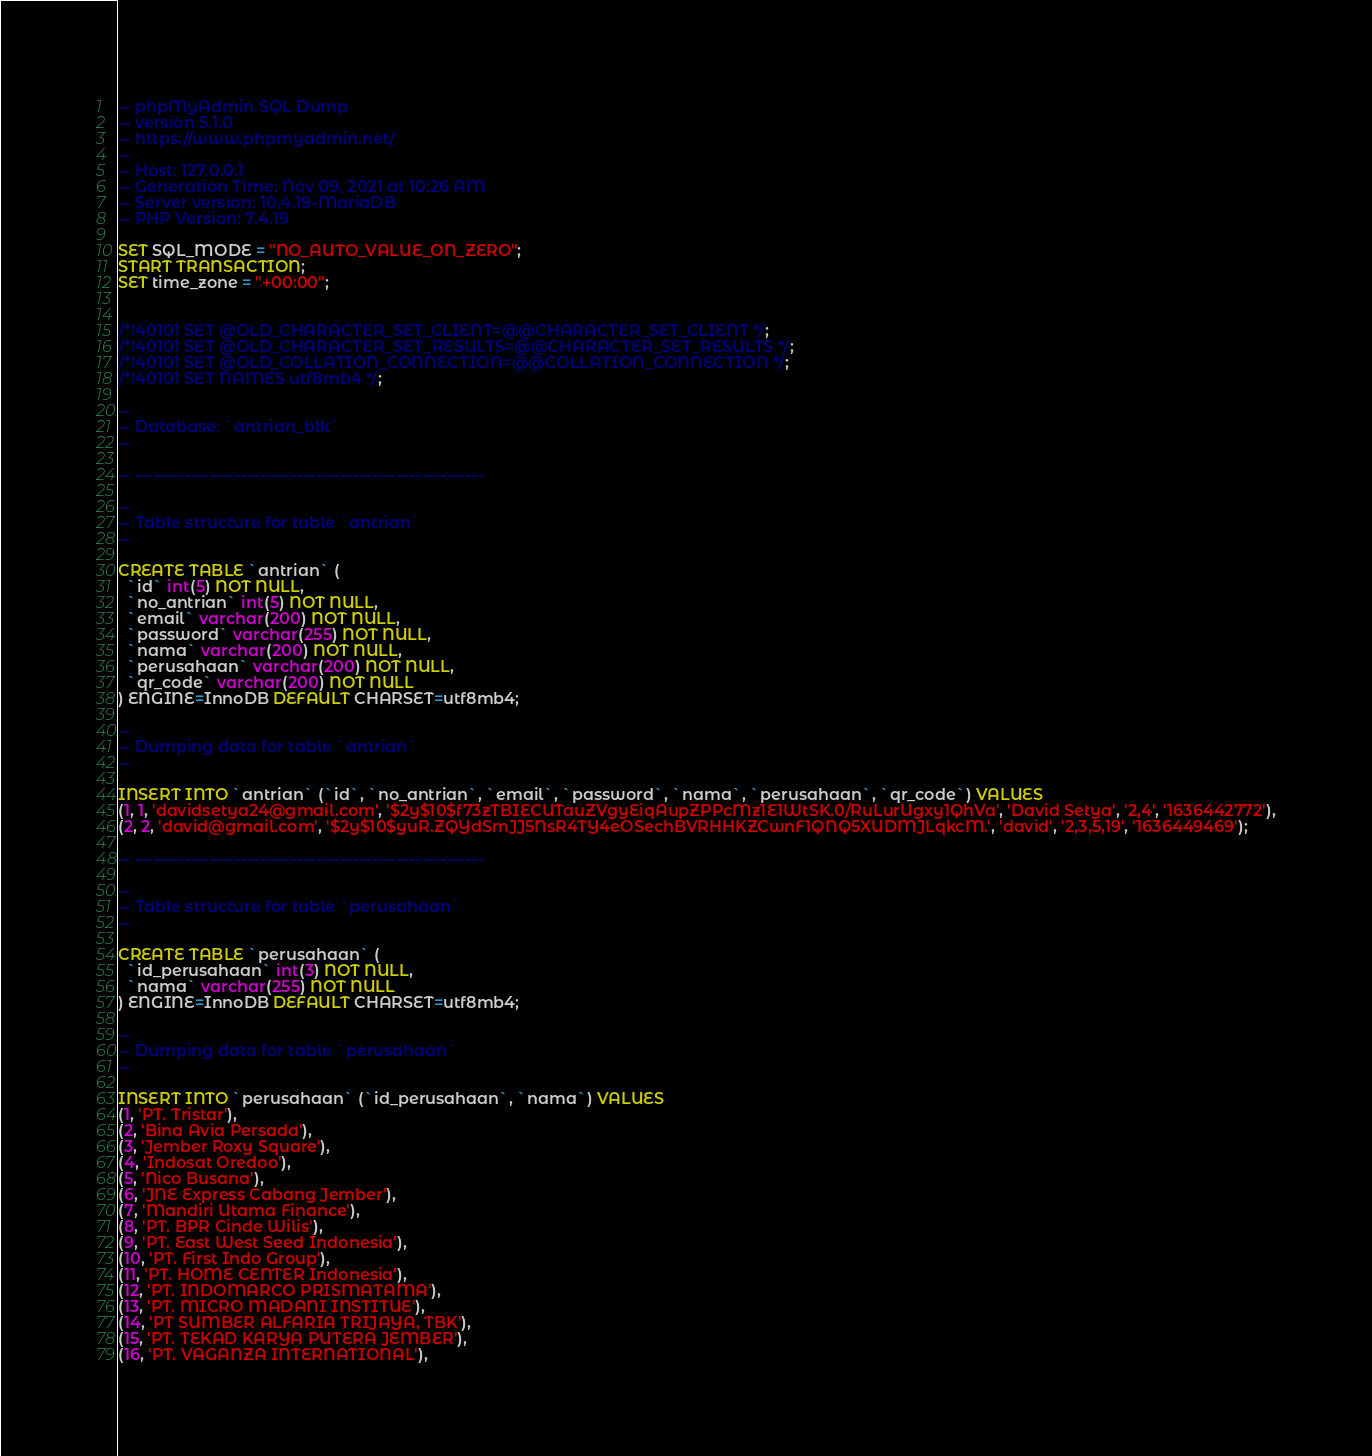<code> <loc_0><loc_0><loc_500><loc_500><_SQL_>-- phpMyAdmin SQL Dump
-- version 5.1.0
-- https://www.phpmyadmin.net/
--
-- Host: 127.0.0.1
-- Generation Time: Nov 09, 2021 at 10:26 AM
-- Server version: 10.4.19-MariaDB
-- PHP Version: 7.4.19

SET SQL_MODE = "NO_AUTO_VALUE_ON_ZERO";
START TRANSACTION;
SET time_zone = "+00:00";


/*!40101 SET @OLD_CHARACTER_SET_CLIENT=@@CHARACTER_SET_CLIENT */;
/*!40101 SET @OLD_CHARACTER_SET_RESULTS=@@CHARACTER_SET_RESULTS */;
/*!40101 SET @OLD_COLLATION_CONNECTION=@@COLLATION_CONNECTION */;
/*!40101 SET NAMES utf8mb4 */;

--
-- Database: `antrian_blk`
--

-- --------------------------------------------------------

--
-- Table structure for table `antrian`
--

CREATE TABLE `antrian` (
  `id` int(5) NOT NULL,
  `no_antrian` int(5) NOT NULL,
  `email` varchar(200) NOT NULL,
  `password` varchar(255) NOT NULL,
  `nama` varchar(200) NOT NULL,
  `perusahaan` varchar(200) NOT NULL,
  `qr_code` varchar(200) NOT NULL
) ENGINE=InnoDB DEFAULT CHARSET=utf8mb4;

--
-- Dumping data for table `antrian`
--

INSERT INTO `antrian` (`id`, `no_antrian`, `email`, `password`, `nama`, `perusahaan`, `qr_code`) VALUES
(1, 1, 'davidsetya24@gmail.com', '$2y$10$f73zTBIECUTauZVgyEiqAupZPPcMz1E1WtSK.0/RuLurUgxy1QhVa', 'David Setya', '2,4', '1636442772'),
(2, 2, 'david@gmail.com', '$2y$10$yuR.ZQYdSmJJ5NsR4TY4eOSechBVRHHKZCwnF1QNQ5XUDMJLqkcM.', 'david', '2,3,5,19', '1636449469');

-- --------------------------------------------------------

--
-- Table structure for table `perusahaan`
--

CREATE TABLE `perusahaan` (
  `id_perusahaan` int(3) NOT NULL,
  `nama` varchar(255) NOT NULL
) ENGINE=InnoDB DEFAULT CHARSET=utf8mb4;

--
-- Dumping data for table `perusahaan`
--

INSERT INTO `perusahaan` (`id_perusahaan`, `nama`) VALUES
(1, 'PT. Tristar'),
(2, 'Bina Avia Persada'),
(3, 'Jember Roxy Square'),
(4, 'Indosat Oredoo'),
(5, 'Nico Busana'),
(6, 'JNE Express Cabang Jember'),
(7, 'Mandiri Utama Finance'),
(8, 'PT. BPR Cinde Wilis'),
(9, 'PT. East West Seed Indonesia'),
(10, 'PT. First Indo Group'),
(11, 'PT. HOME CENTER Indonesia'),
(12, 'PT. INDOMARCO PRISMATAMA'),
(13, 'PT. MICRO MADANI INSTITUE'),
(14, 'PT SUMBER ALFARIA TRIJAYA, TBK'),
(15, 'PT. TEKAD KARYA PUTERA JEMBER'),
(16, 'PT. VAGANZA INTERNATIONAL'),</code> 